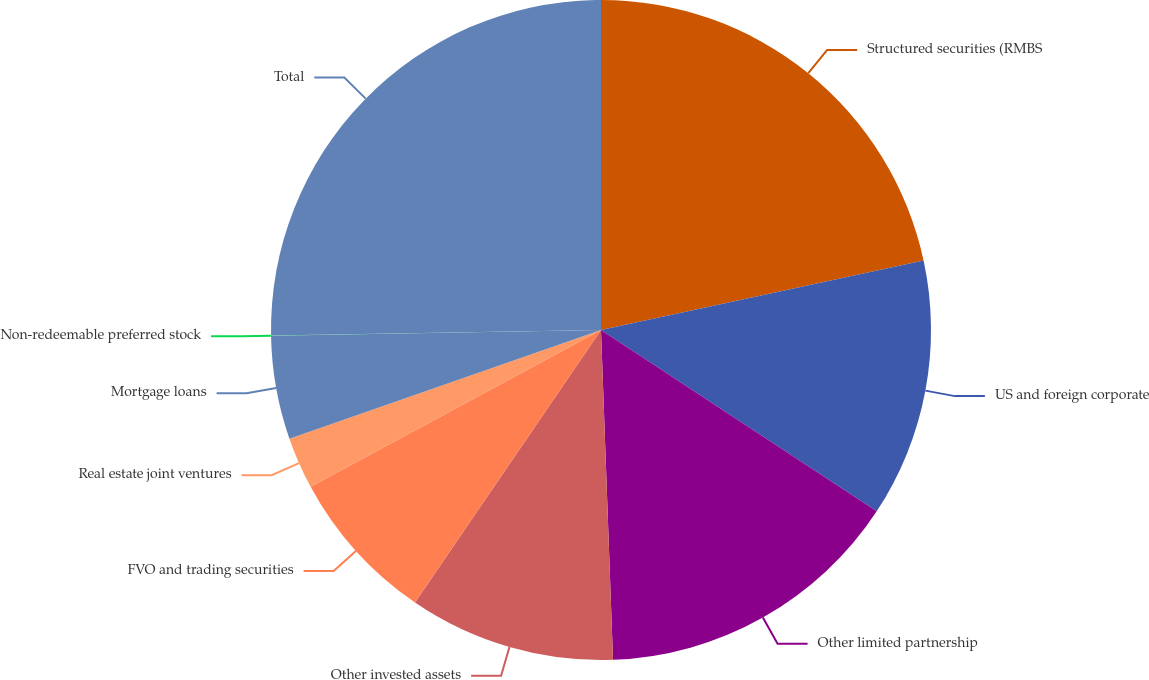Convert chart. <chart><loc_0><loc_0><loc_500><loc_500><pie_chart><fcel>Structured securities (RMBS<fcel>US and foreign corporate<fcel>Other limited partnership<fcel>Other invested assets<fcel>FVO and trading securities<fcel>Real estate joint ventures<fcel>Mortgage loans<fcel>Non-redeemable preferred stock<fcel>Total<nl><fcel>21.62%<fcel>12.64%<fcel>15.16%<fcel>10.11%<fcel>7.59%<fcel>2.54%<fcel>5.06%<fcel>0.01%<fcel>25.27%<nl></chart> 